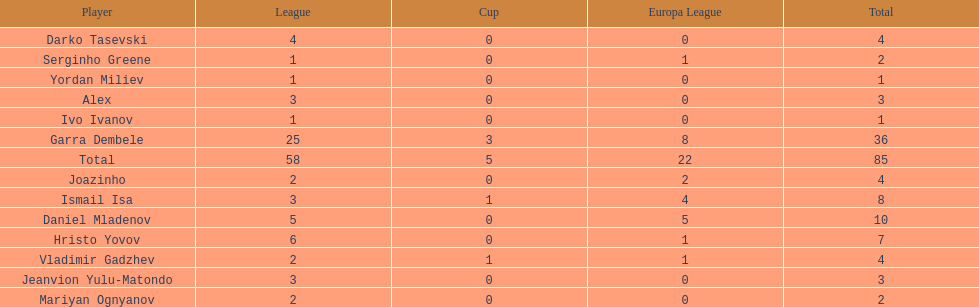Who was the top goalscorer on this team? Garra Dembele. 